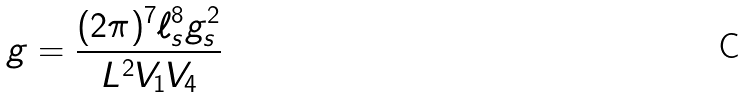Convert formula to latex. <formula><loc_0><loc_0><loc_500><loc_500>g = \frac { ( 2 \pi ) ^ { 7 } \ell _ { s } ^ { 8 } g _ { s } ^ { 2 } } { L ^ { 2 } V _ { 1 } V _ { 4 } }</formula> 